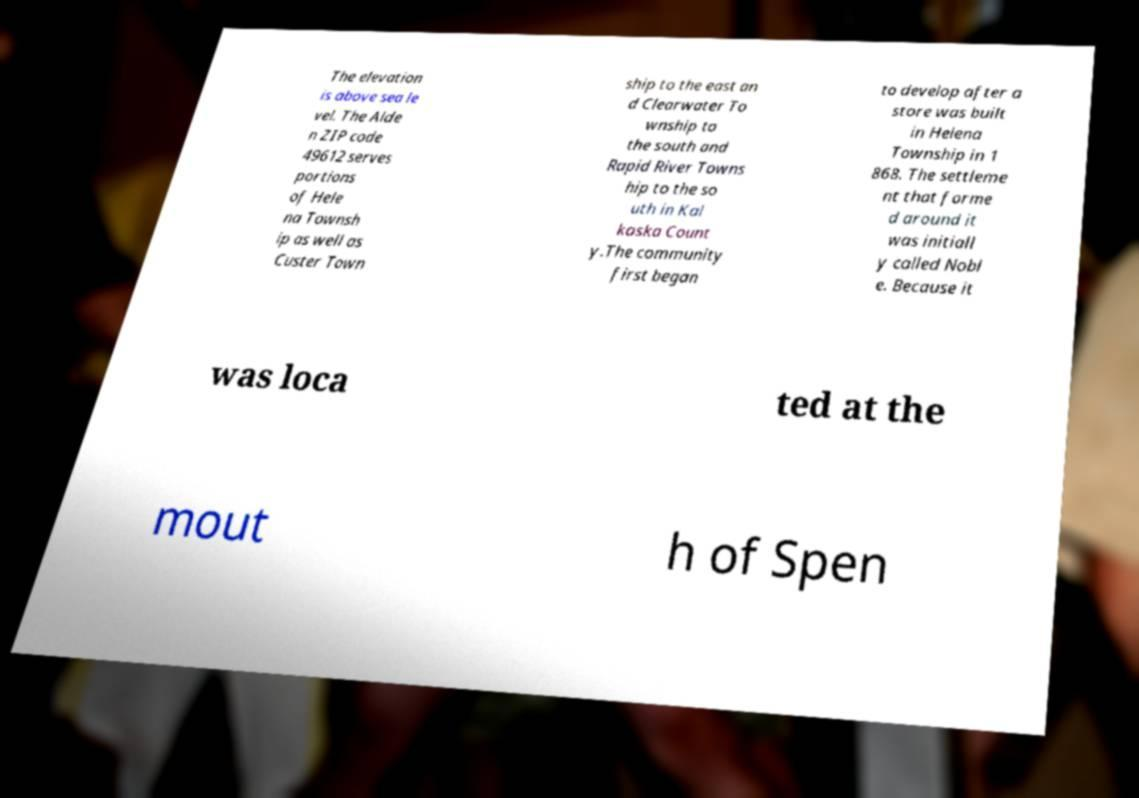Could you extract and type out the text from this image? The elevation is above sea le vel. The Alde n ZIP code 49612 serves portions of Hele na Townsh ip as well as Custer Town ship to the east an d Clearwater To wnship to the south and Rapid River Towns hip to the so uth in Kal kaska Count y.The community first began to develop after a store was built in Helena Township in 1 868. The settleme nt that forme d around it was initiall y called Nobl e. Because it was loca ted at the mout h of Spen 